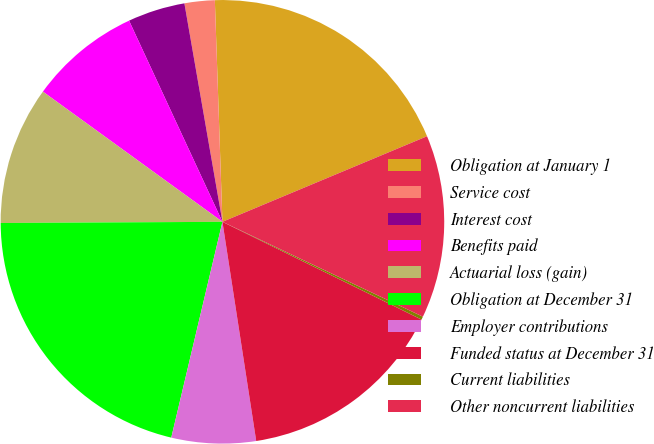<chart> <loc_0><loc_0><loc_500><loc_500><pie_chart><fcel>Obligation at January 1<fcel>Service cost<fcel>Interest cost<fcel>Benefits paid<fcel>Actuarial loss (gain)<fcel>Obligation at December 31<fcel>Employer contributions<fcel>Funded status at December 31<fcel>Current liabilities<fcel>Other noncurrent liabilities<nl><fcel>19.24%<fcel>2.2%<fcel>4.17%<fcel>8.1%<fcel>10.07%<fcel>21.21%<fcel>6.14%<fcel>15.3%<fcel>0.23%<fcel>13.34%<nl></chart> 